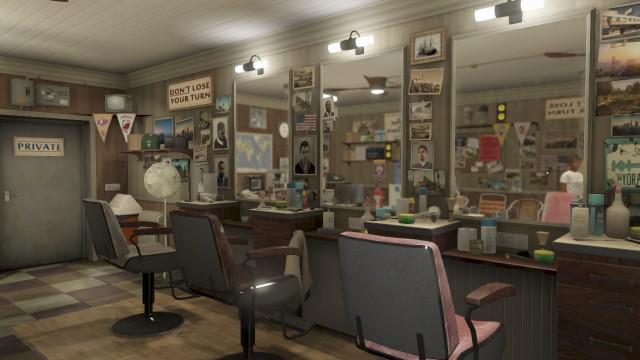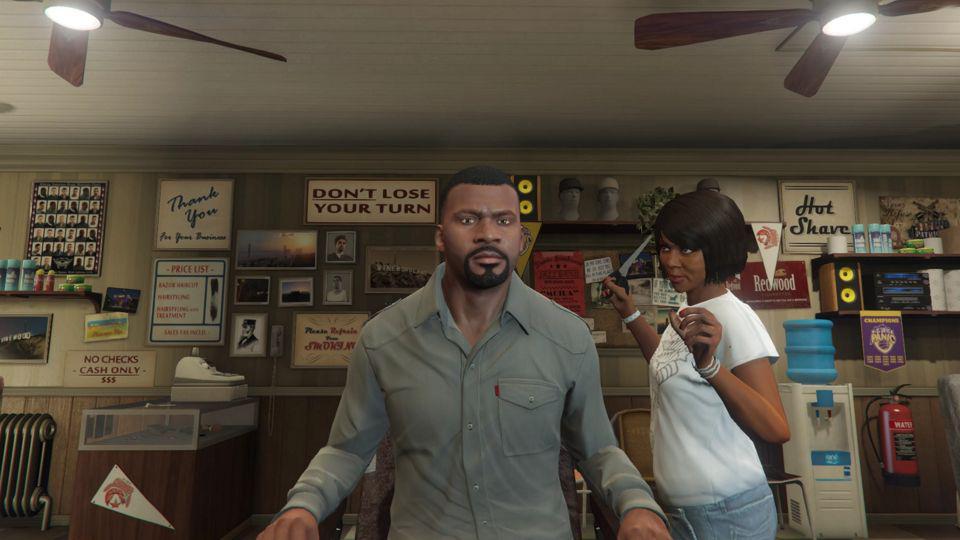The first image is the image on the left, the second image is the image on the right. Analyze the images presented: Is the assertion "An image shows a black female barber holding scissors and standing behind a forward-facing male with his hands on armrests." valid? Answer yes or no. Yes. 